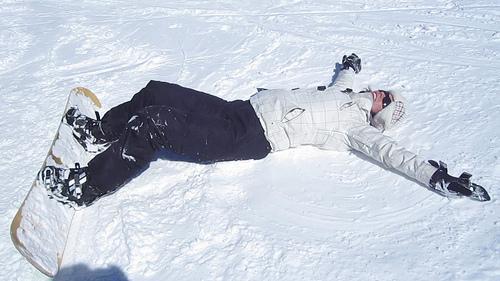How many people are pictured?
Give a very brief answer. 1. How many train cars are there?
Give a very brief answer. 0. 